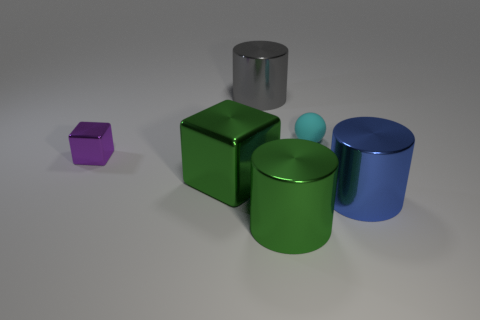Are there an equal number of purple objects that are right of the green cylinder and green cylinders?
Offer a terse response. No. The block that is on the right side of the purple object that is behind the big green thing that is behind the green metallic cylinder is made of what material?
Keep it short and to the point. Metal. Are there any cyan balls that have the same size as the cyan thing?
Your answer should be very brief. No. There is a cyan rubber object; what shape is it?
Offer a very short reply. Sphere. What number of balls are either purple things or cyan rubber objects?
Offer a very short reply. 1. Are there the same number of matte things behind the small cyan sphere and small purple cubes on the right side of the tiny purple metal thing?
Your answer should be very brief. Yes. What number of large green shiny things are left of the big green metallic object that is on the right side of the big object that is on the left side of the big gray shiny cylinder?
Provide a succinct answer. 1. There is a big object that is the same color as the large metal cube; what shape is it?
Your response must be concise. Cylinder. There is a matte ball; is its color the same as the tiny thing to the left of the large gray object?
Offer a terse response. No. Is the number of cyan matte spheres that are to the left of the large gray metal thing greater than the number of big cylinders?
Your answer should be compact. No. 